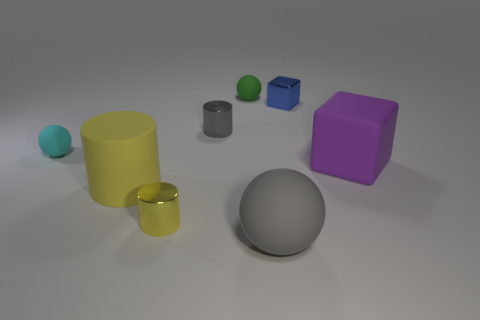Add 1 small red matte cylinders. How many objects exist? 9 Subtract all purple spheres. Subtract all blue cubes. How many spheres are left? 3 Subtract all spheres. How many objects are left? 5 Add 3 large matte things. How many large matte things are left? 6 Add 6 balls. How many balls exist? 9 Subtract 0 red cylinders. How many objects are left? 8 Subtract all large things. Subtract all small brown shiny cylinders. How many objects are left? 5 